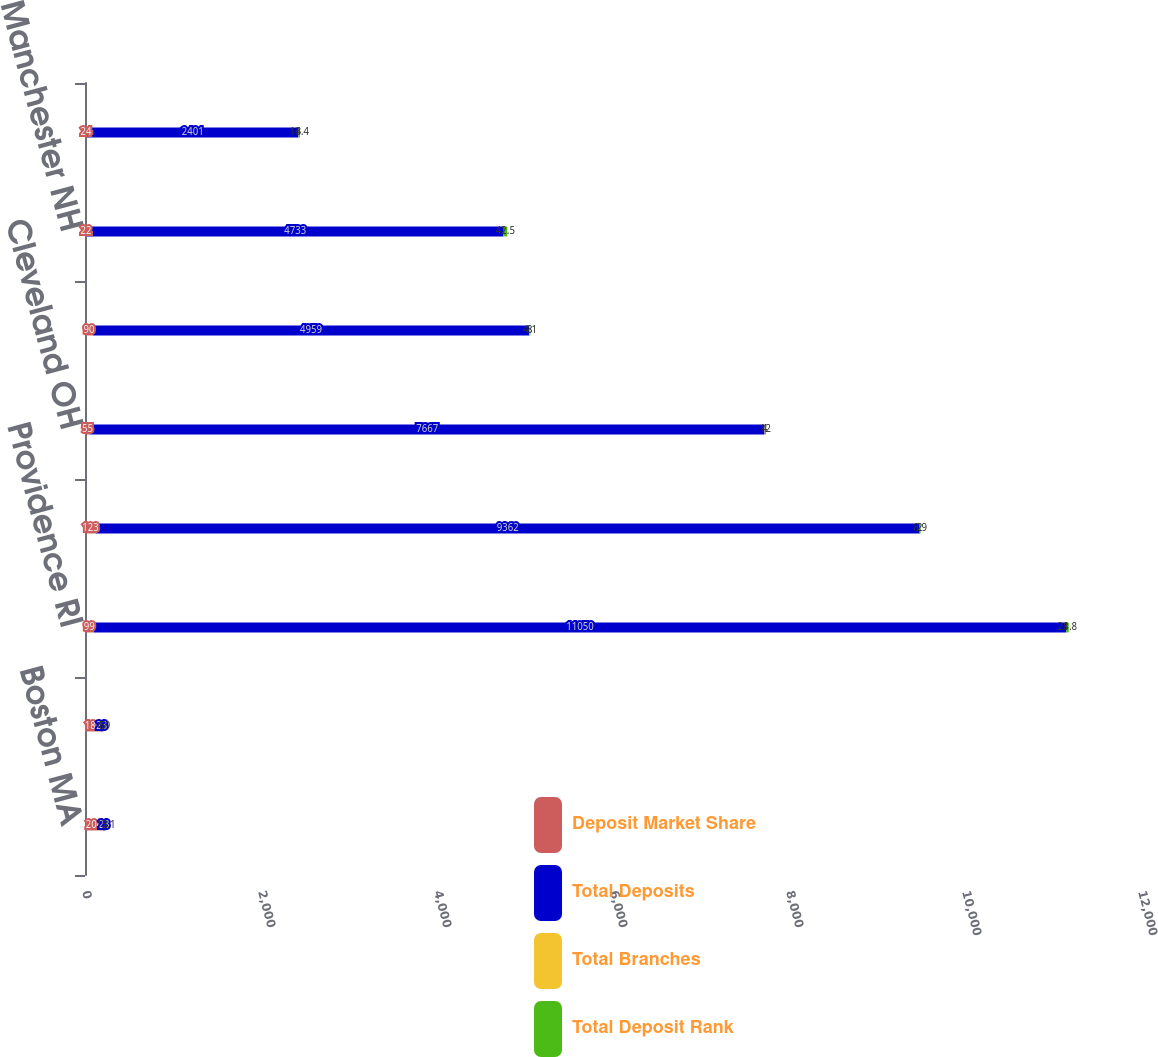Convert chart. <chart><loc_0><loc_0><loc_500><loc_500><stacked_bar_chart><ecel><fcel>Boston MA<fcel>Philadelphia PA<fcel>Providence RI<fcel>Pittsburgh PA<fcel>Cleveland OH<fcel>Detroit MI<fcel>Manchester NH<fcel>Albany NY<nl><fcel>Deposit Market Share<fcel>204<fcel>180<fcel>99<fcel>123<fcel>55<fcel>90<fcel>22<fcel>24<nl><fcel>Total Deposits<fcel>23<fcel>23<fcel>11050<fcel>9362<fcel>7667<fcel>4959<fcel>4733<fcel>2401<nl><fcel>Total Branches<fcel>2<fcel>5<fcel>1<fcel>2<fcel>4<fcel>8<fcel>1<fcel>3<nl><fcel>Total Deposit Rank<fcel>15.1<fcel>4.9<fcel>28.8<fcel>8.9<fcel>12<fcel>4.1<fcel>42.5<fcel>14.4<nl></chart> 